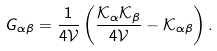<formula> <loc_0><loc_0><loc_500><loc_500>G _ { \alpha \beta } = \frac { 1 } { 4 \mathcal { V } } \left ( \frac { \mathcal { K } _ { \alpha } \mathcal { K } _ { \beta } } { 4 \mathcal { V } } - \mathcal { K } _ { \alpha \beta } \right ) .</formula> 